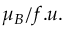Convert formula to latex. <formula><loc_0><loc_0><loc_500><loc_500>\mu _ { B } / f . u .</formula> 